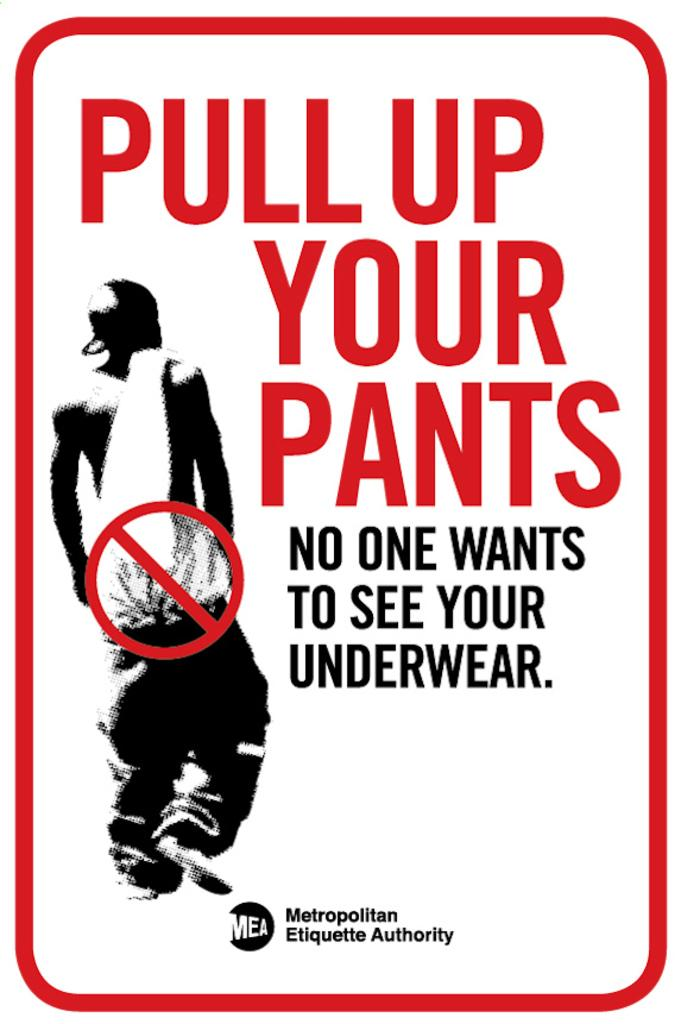Provide a one-sentence caption for the provided image. A post for Pull up your pant by Metropolitan Etiquette Authority. 